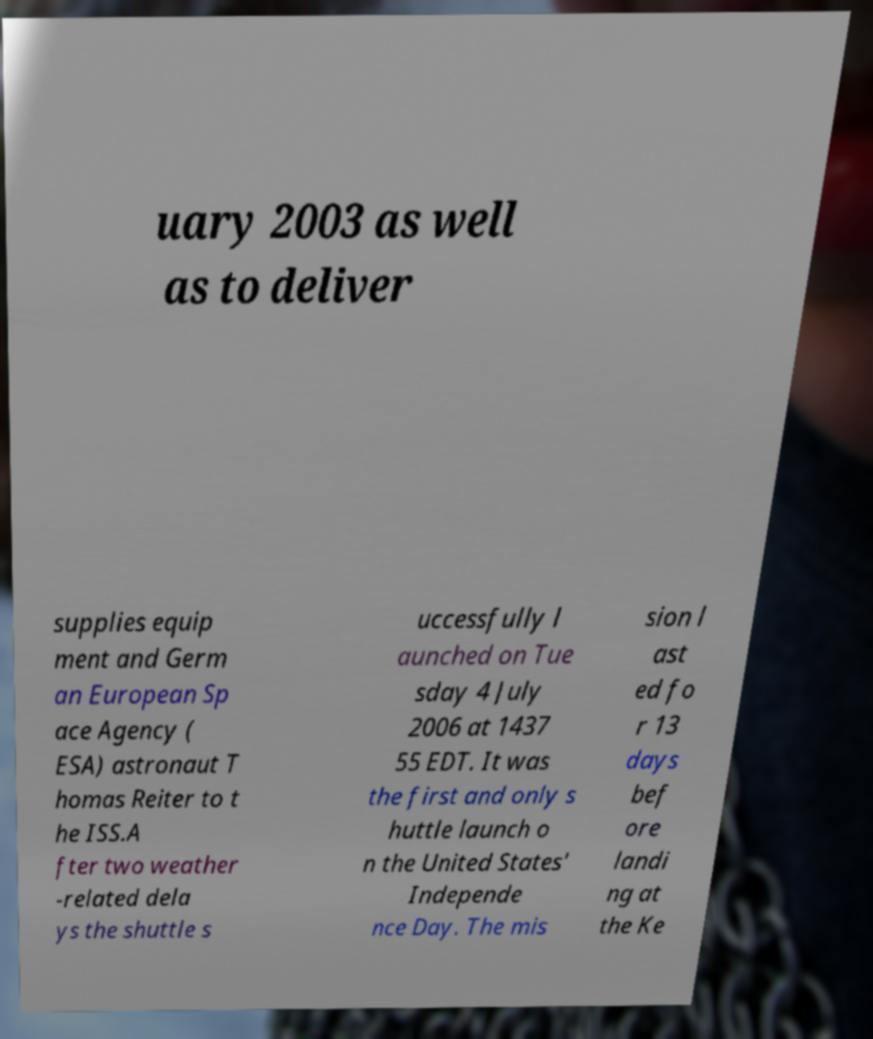Could you assist in decoding the text presented in this image and type it out clearly? uary 2003 as well as to deliver supplies equip ment and Germ an European Sp ace Agency ( ESA) astronaut T homas Reiter to t he ISS.A fter two weather -related dela ys the shuttle s uccessfully l aunched on Tue sday 4 July 2006 at 1437 55 EDT. It was the first and only s huttle launch o n the United States' Independe nce Day. The mis sion l ast ed fo r 13 days bef ore landi ng at the Ke 